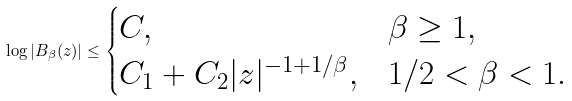Convert formula to latex. <formula><loc_0><loc_0><loc_500><loc_500>\log | B _ { \beta } ( z ) | \leq \begin{cases} C , & \beta \geq 1 , \\ C _ { 1 } + C _ { 2 } | z | ^ { - 1 + 1 / \beta } , & 1 / 2 < \beta < 1 . \end{cases}</formula> 